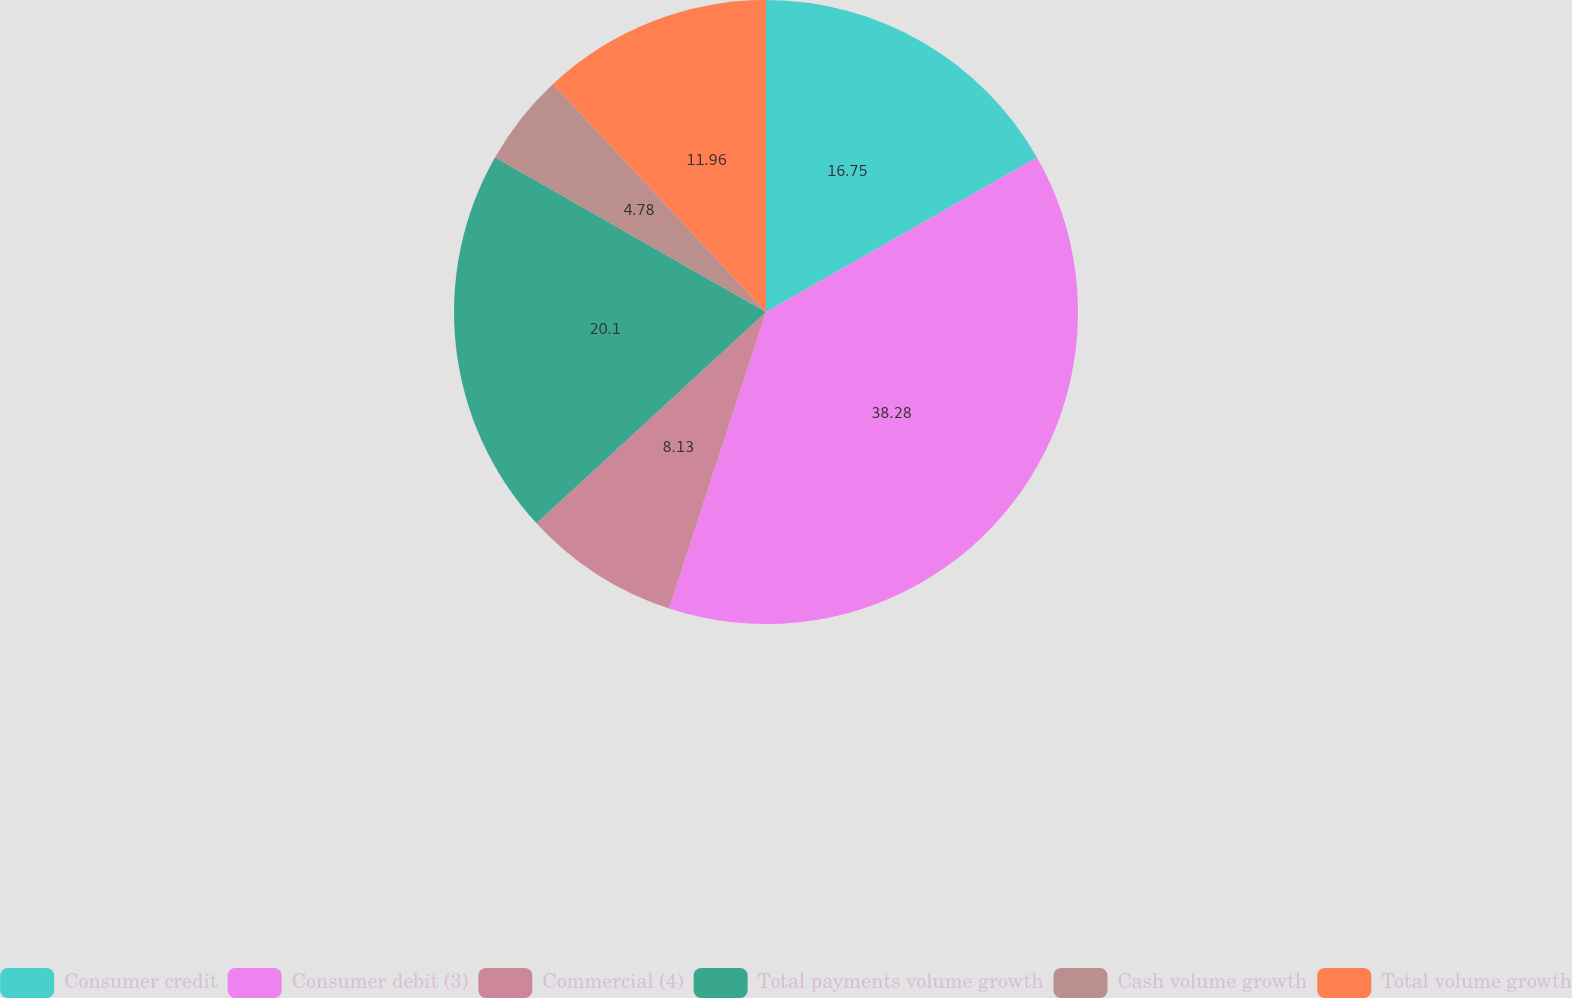Convert chart. <chart><loc_0><loc_0><loc_500><loc_500><pie_chart><fcel>Consumer credit<fcel>Consumer debit (3)<fcel>Commercial (4)<fcel>Total payments volume growth<fcel>Cash volume growth<fcel>Total volume growth<nl><fcel>16.75%<fcel>38.28%<fcel>8.13%<fcel>20.1%<fcel>4.78%<fcel>11.96%<nl></chart> 